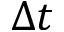<formula> <loc_0><loc_0><loc_500><loc_500>\Delta t</formula> 